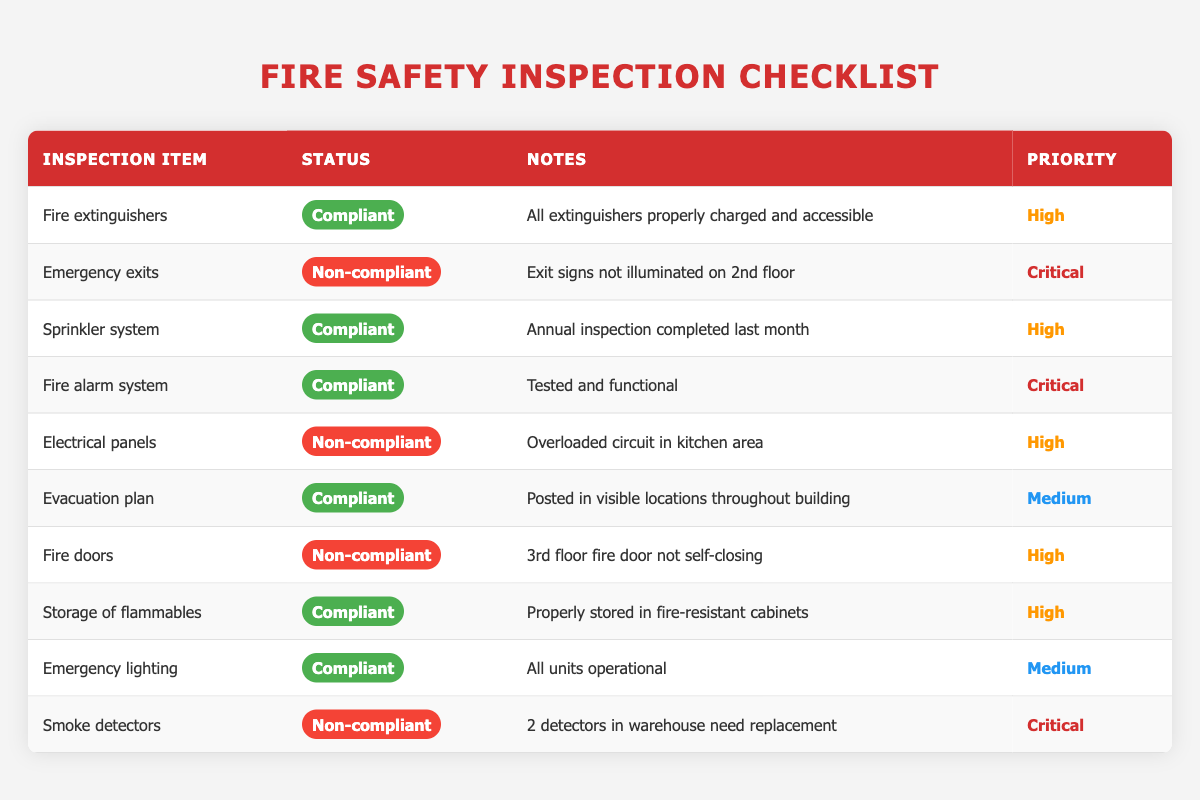What is the status of the fire extinguishers? The fire extinguishers are listed as "Compliant" in the Status column. It indicates that they meet the required safety standards.
Answer: Compliant How many inspections reported a critical priority status? There are three items marked with a "Critical" priority status: Emergency exits, Fire alarm system, and Smoke detectors. Therefore, the count is three.
Answer: 3 Are all fire doors compliant? No, according to the table, the fire doors are "Non-compliant" as noted in the Status column for the 3rd floor fire door, which is not self-closing.
Answer: No What is the note associated with the emergency exits? The note states that the exit signs are not illuminated on the 2nd floor, indicating a safety concern that needs to be addressed.
Answer: Exit signs not illuminated on 2nd floor What is the total number of compliant inspection items? Counting the "Compliant" inspection items listed: Fire extinguishers, Sprinkler system, Fire alarm system, Evacuation plan, Storage of flammables, Emergency lighting gives a total of six compliant items.
Answer: 6 How many inspection items have overloaded circuits noted in their observations? The only inspection item that mentions an overloaded circuit is the Electrical panels. Thus, there is one item with this observation.
Answer: 1 Which inspection item has the highest priority status? The inspection items with "Critical" priority status are Emergency exits, Fire alarm system, and Smoke detectors. All three share the highest priority.
Answer: Emergency exits, Fire alarm system, Smoke detectors Is the evacuation plan compliant? Yes, the evacuation plan is marked as "Compliant" and is noted to be posted in visible locations throughout the building, fulfilling safety requirements.
Answer: Yes What note is provided for smoke detectors? The note states that two smoke detectors in the warehouse need replacement, highlighting the issue to be resolved.
Answer: 2 detectors in warehouse need replacement What is the only item listed with a medium priority? The items with a medium priority are the evacuation plan and emergency lighting. Since both fall into this category, they are noted respectively.
Answer: Evacuation plan, Emergency lighting 